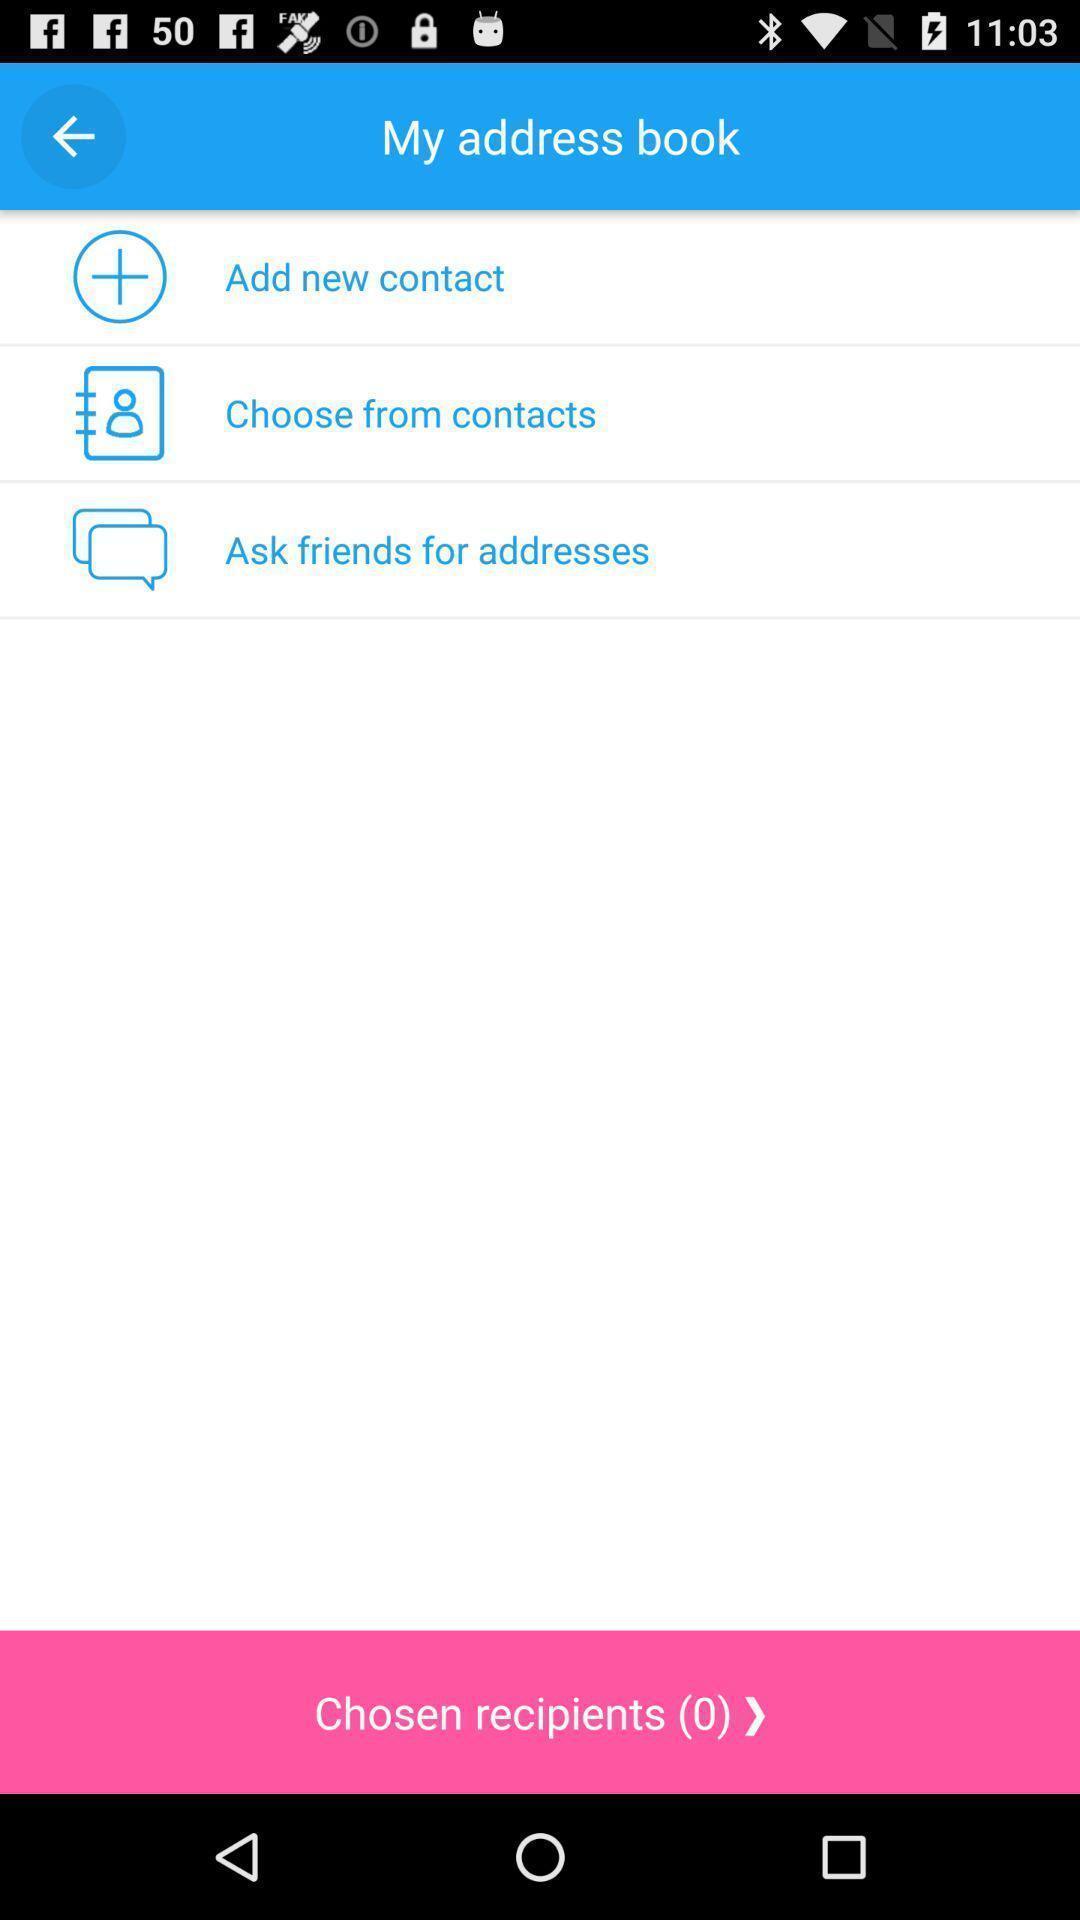What details can you identify in this image? Social app showing list of address book. 